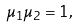Convert formula to latex. <formula><loc_0><loc_0><loc_500><loc_500>\mu _ { 1 } \mu _ { 2 } = 1 ,</formula> 